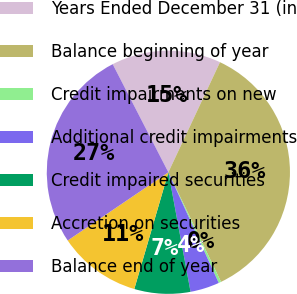Convert chart to OTSL. <chart><loc_0><loc_0><loc_500><loc_500><pie_chart><fcel>Years Ended December 31 (in<fcel>Balance beginning of year<fcel>Credit impairments on new<fcel>Additional credit impairments<fcel>Credit impaired securities<fcel>Accretion on securities<fcel>Balance end of year<nl><fcel>14.55%<fcel>35.89%<fcel>0.33%<fcel>3.88%<fcel>7.44%<fcel>11.0%<fcel>26.91%<nl></chart> 